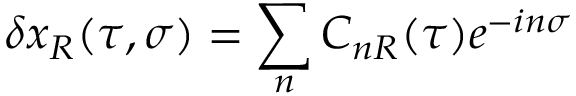Convert formula to latex. <formula><loc_0><loc_0><loc_500><loc_500>\delta x _ { R } ( \tau , \sigma ) = \sum _ { n } C _ { n R } ( \tau ) e ^ { - i n \sigma }</formula> 